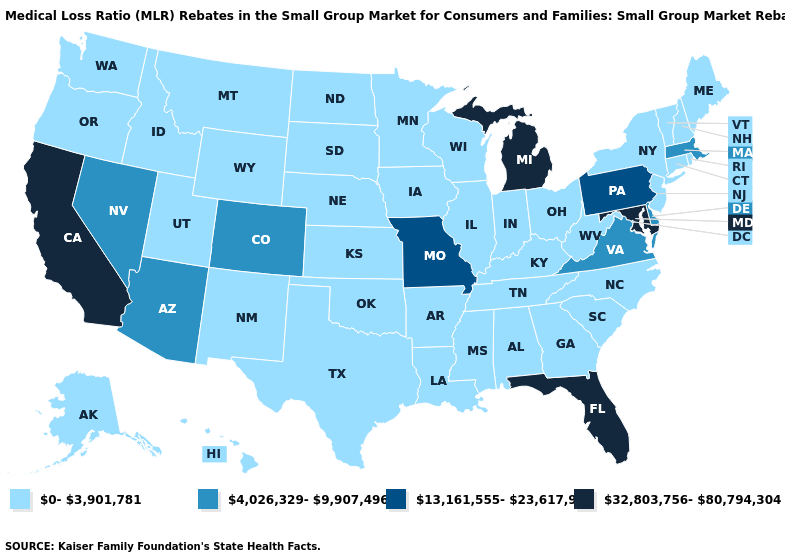What is the value of Massachusetts?
Be succinct. 4,026,329-9,907,496. Does Iowa have the lowest value in the MidWest?
Write a very short answer. Yes. Name the states that have a value in the range 4,026,329-9,907,496?
Write a very short answer. Arizona, Colorado, Delaware, Massachusetts, Nevada, Virginia. What is the highest value in the Northeast ?
Write a very short answer. 13,161,555-23,617,952. Does Florida have the highest value in the USA?
Write a very short answer. Yes. Which states have the lowest value in the USA?
Give a very brief answer. Alabama, Alaska, Arkansas, Connecticut, Georgia, Hawaii, Idaho, Illinois, Indiana, Iowa, Kansas, Kentucky, Louisiana, Maine, Minnesota, Mississippi, Montana, Nebraska, New Hampshire, New Jersey, New Mexico, New York, North Carolina, North Dakota, Ohio, Oklahoma, Oregon, Rhode Island, South Carolina, South Dakota, Tennessee, Texas, Utah, Vermont, Washington, West Virginia, Wisconsin, Wyoming. Does Georgia have the highest value in the South?
Write a very short answer. No. Does Arizona have the same value as Massachusetts?
Give a very brief answer. Yes. Name the states that have a value in the range 0-3,901,781?
Concise answer only. Alabama, Alaska, Arkansas, Connecticut, Georgia, Hawaii, Idaho, Illinois, Indiana, Iowa, Kansas, Kentucky, Louisiana, Maine, Minnesota, Mississippi, Montana, Nebraska, New Hampshire, New Jersey, New Mexico, New York, North Carolina, North Dakota, Ohio, Oklahoma, Oregon, Rhode Island, South Carolina, South Dakota, Tennessee, Texas, Utah, Vermont, Washington, West Virginia, Wisconsin, Wyoming. Which states have the lowest value in the USA?
Quick response, please. Alabama, Alaska, Arkansas, Connecticut, Georgia, Hawaii, Idaho, Illinois, Indiana, Iowa, Kansas, Kentucky, Louisiana, Maine, Minnesota, Mississippi, Montana, Nebraska, New Hampshire, New Jersey, New Mexico, New York, North Carolina, North Dakota, Ohio, Oklahoma, Oregon, Rhode Island, South Carolina, South Dakota, Tennessee, Texas, Utah, Vermont, Washington, West Virginia, Wisconsin, Wyoming. What is the highest value in the South ?
Answer briefly. 32,803,756-80,794,304. Does the first symbol in the legend represent the smallest category?
Write a very short answer. Yes. Name the states that have a value in the range 13,161,555-23,617,952?
Concise answer only. Missouri, Pennsylvania. Name the states that have a value in the range 0-3,901,781?
Short answer required. Alabama, Alaska, Arkansas, Connecticut, Georgia, Hawaii, Idaho, Illinois, Indiana, Iowa, Kansas, Kentucky, Louisiana, Maine, Minnesota, Mississippi, Montana, Nebraska, New Hampshire, New Jersey, New Mexico, New York, North Carolina, North Dakota, Ohio, Oklahoma, Oregon, Rhode Island, South Carolina, South Dakota, Tennessee, Texas, Utah, Vermont, Washington, West Virginia, Wisconsin, Wyoming. Name the states that have a value in the range 0-3,901,781?
Write a very short answer. Alabama, Alaska, Arkansas, Connecticut, Georgia, Hawaii, Idaho, Illinois, Indiana, Iowa, Kansas, Kentucky, Louisiana, Maine, Minnesota, Mississippi, Montana, Nebraska, New Hampshire, New Jersey, New Mexico, New York, North Carolina, North Dakota, Ohio, Oklahoma, Oregon, Rhode Island, South Carolina, South Dakota, Tennessee, Texas, Utah, Vermont, Washington, West Virginia, Wisconsin, Wyoming. 